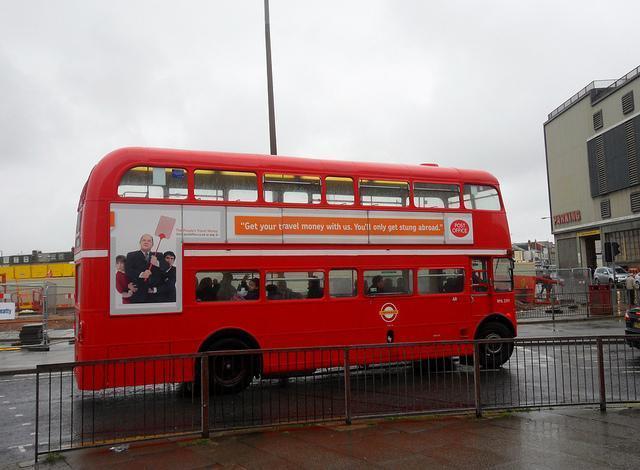How many buses are visible?
Give a very brief answer. 1. 